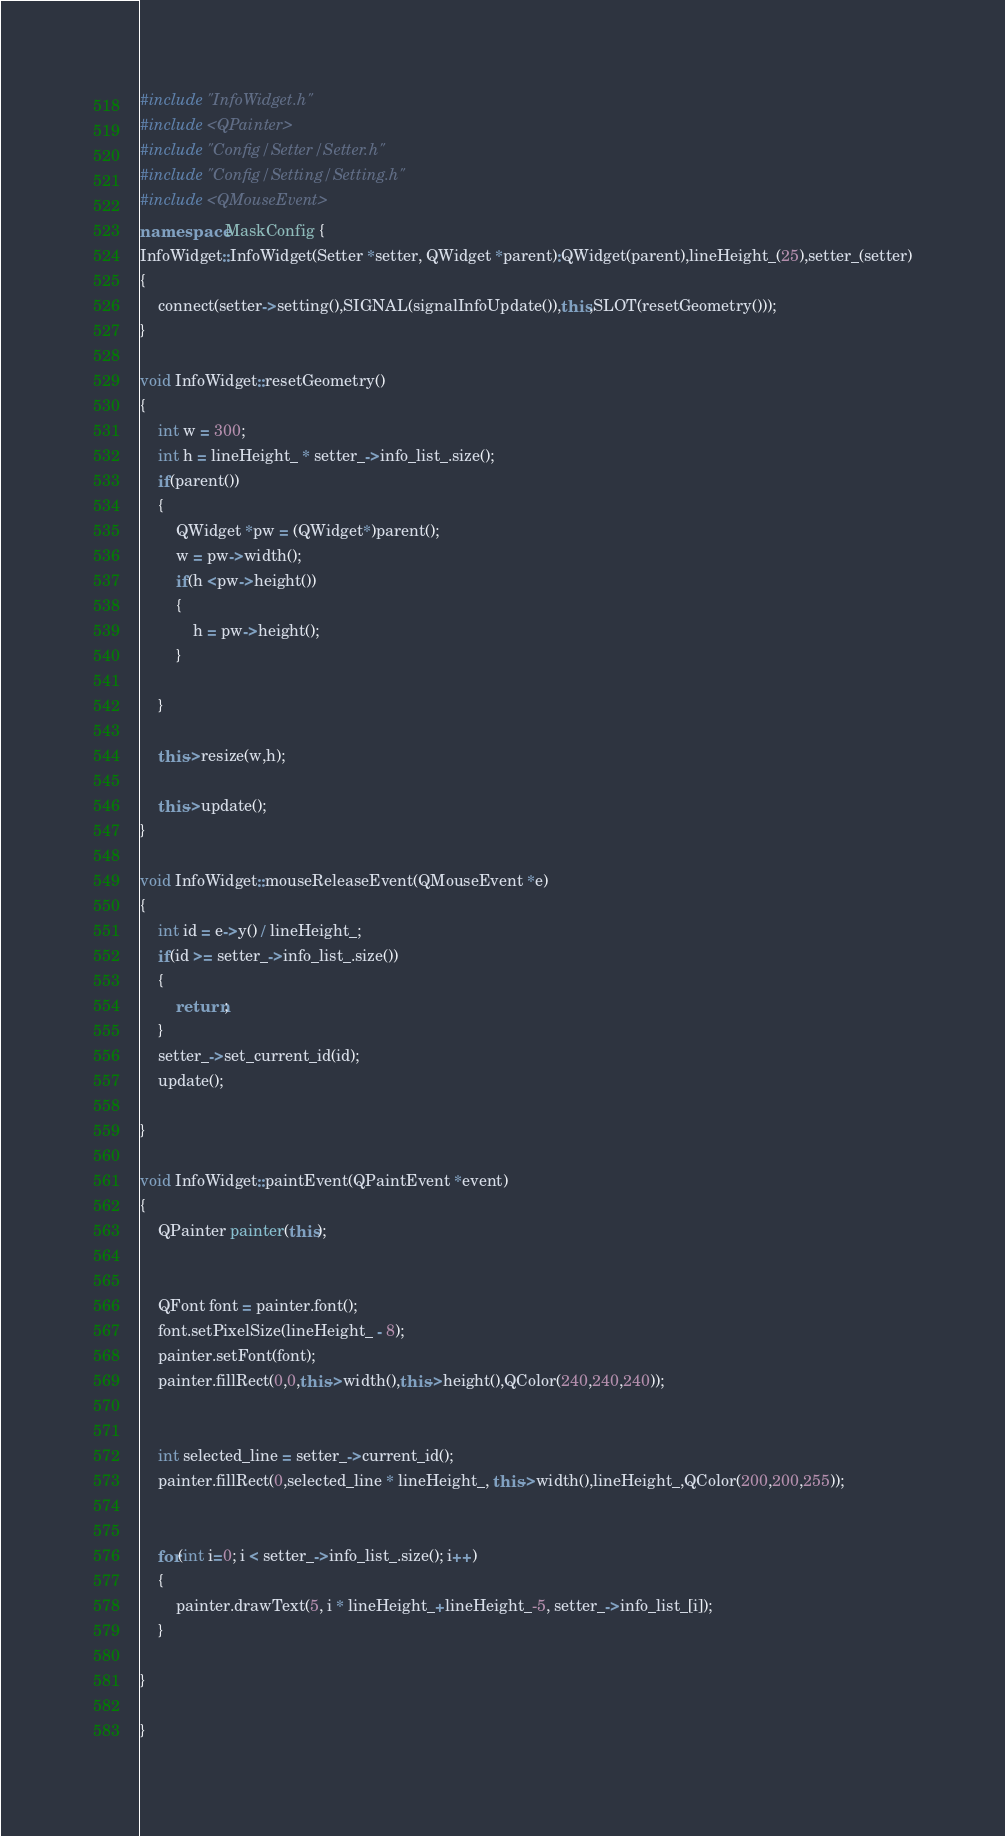Convert code to text. <code><loc_0><loc_0><loc_500><loc_500><_C++_>#include "InfoWidget.h"
#include <QPainter>
#include "Config/Setter/Setter.h"
#include "Config/Setting/Setting.h"
#include <QMouseEvent>
namespace MaskConfig {
InfoWidget::InfoWidget(Setter *setter, QWidget *parent):QWidget(parent),lineHeight_(25),setter_(setter)
{
    connect(setter->setting(),SIGNAL(signalInfoUpdate()),this,SLOT(resetGeometry()));
}

void InfoWidget::resetGeometry()
{
    int w = 300;
    int h = lineHeight_ * setter_->info_list_.size();
    if(parent())
    {
        QWidget *pw = (QWidget*)parent();
        w = pw->width();
        if(h <pw->height())
        {
            h = pw->height();
        }

    }

    this->resize(w,h);

    this->update();
}

void InfoWidget::mouseReleaseEvent(QMouseEvent *e)
{
    int id = e->y() / lineHeight_;
    if(id >= setter_->info_list_.size())
    {
        return;
    }
    setter_->set_current_id(id);
    update();

}

void InfoWidget::paintEvent(QPaintEvent *event)
{
    QPainter painter(this);


    QFont font = painter.font();
    font.setPixelSize(lineHeight_ - 8);
    painter.setFont(font);
    painter.fillRect(0,0,this->width(),this->height(),QColor(240,240,240));


    int selected_line = setter_->current_id();
    painter.fillRect(0,selected_line * lineHeight_, this->width(),lineHeight_,QColor(200,200,255));


    for(int i=0; i < setter_->info_list_.size(); i++)
    {
        painter.drawText(5, i * lineHeight_+lineHeight_-5, setter_->info_list_[i]);
    }

}

}
</code> 